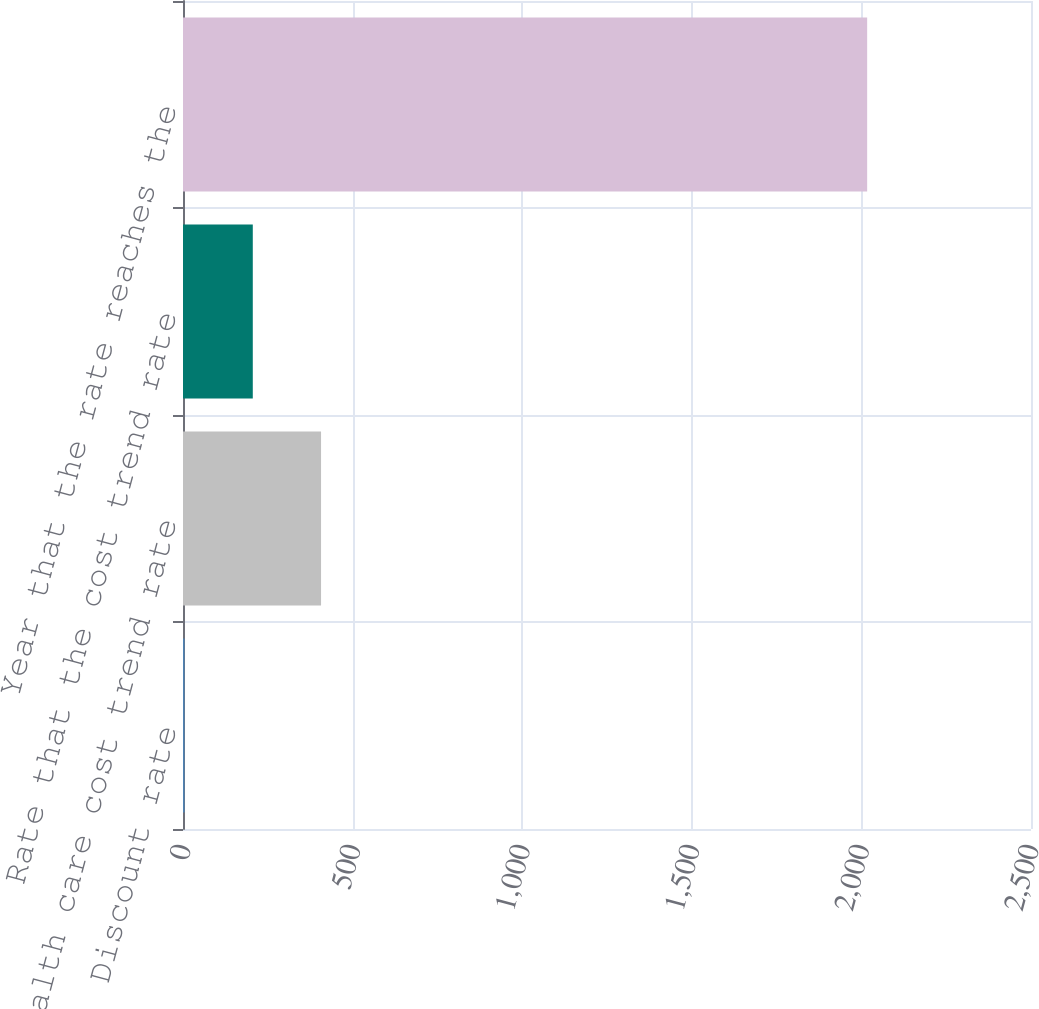<chart> <loc_0><loc_0><loc_500><loc_500><bar_chart><fcel>Discount rate<fcel>Health care cost trend rate<fcel>Rate that the cost trend rate<fcel>Year that the rate reaches the<nl><fcel>4.5<fcel>407<fcel>205.75<fcel>2017<nl></chart> 